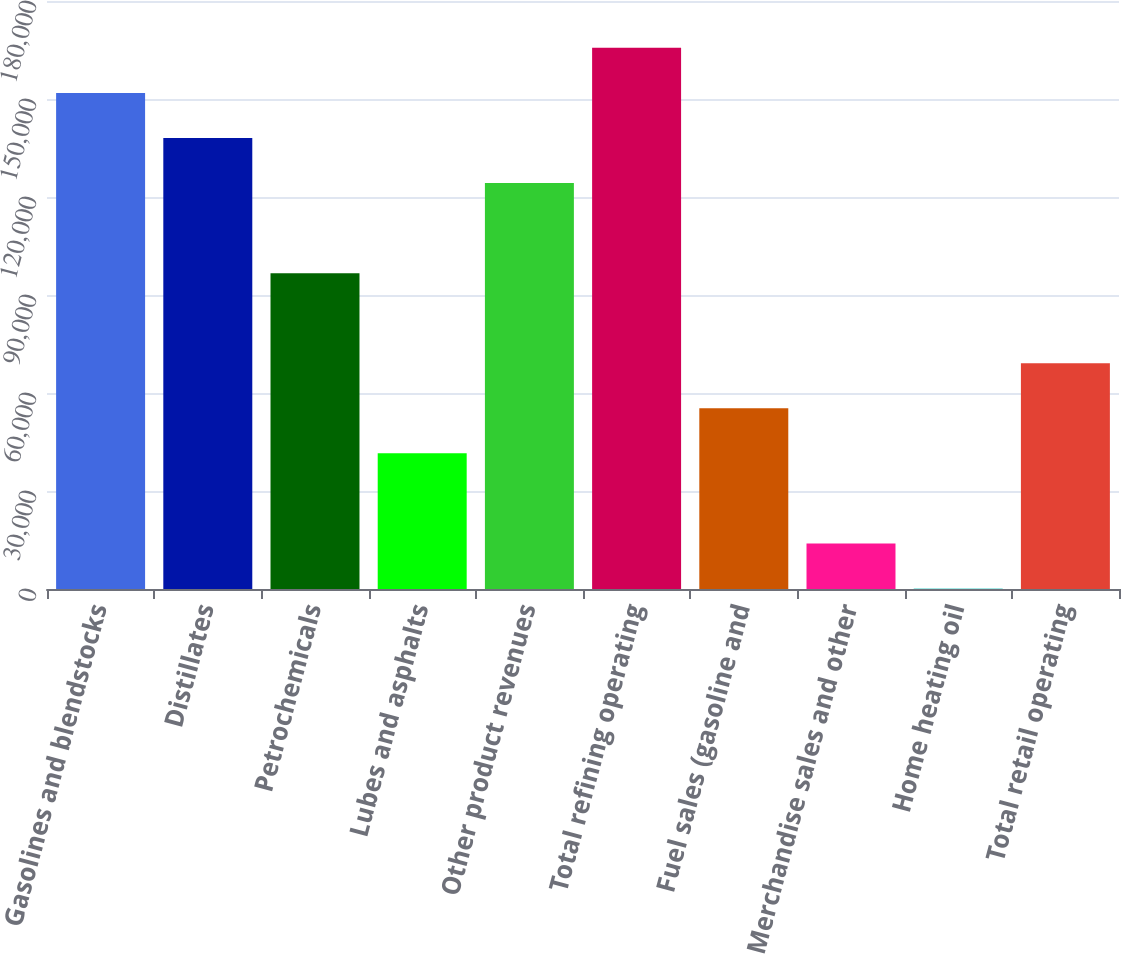Convert chart. <chart><loc_0><loc_0><loc_500><loc_500><bar_chart><fcel>Gasolines and blendstocks<fcel>Distillates<fcel>Petrochemicals<fcel>Lubes and asphalts<fcel>Other product revenues<fcel>Total refining operating<fcel>Fuel sales (gasoline and<fcel>Merchandise sales and other<fcel>Home heating oil<fcel>Total retail operating<nl><fcel>151867<fcel>138074<fcel>96695.6<fcel>41524.4<fcel>124281<fcel>165660<fcel>55317.2<fcel>13938.8<fcel>146<fcel>69110<nl></chart> 